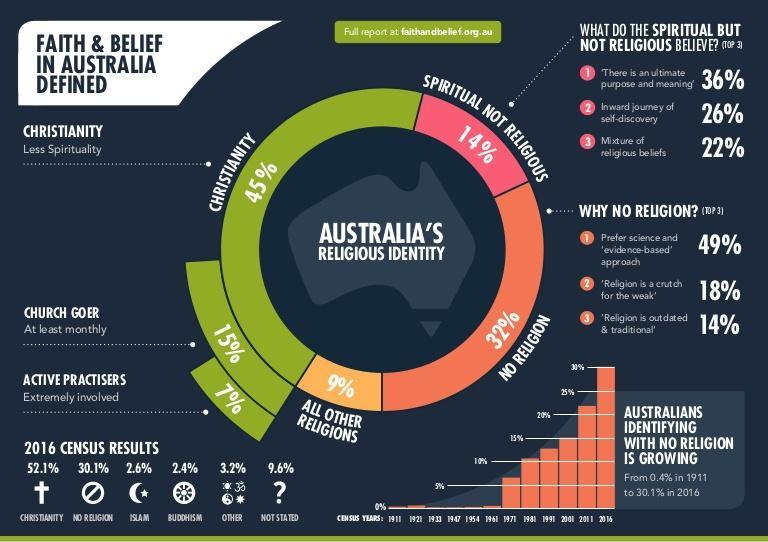What percentage of people practice Buddhism according to the 2016 census results in Australia?
Answer the question with a short phrase. 2.4% What percentage of people are from other religion according to the 2016 census results in Australia? 3.2% What percentage of people practice islam according to 2016 census results in Australia? 2.6% Who believes in the inward journey of self-discovery? Spiritual but not religious What percentage of people did not state their religion according to the 2016 census results in Australia? 9.6% What percentage of people have no religion according to the 2016 census results in Australia? 30.1% 